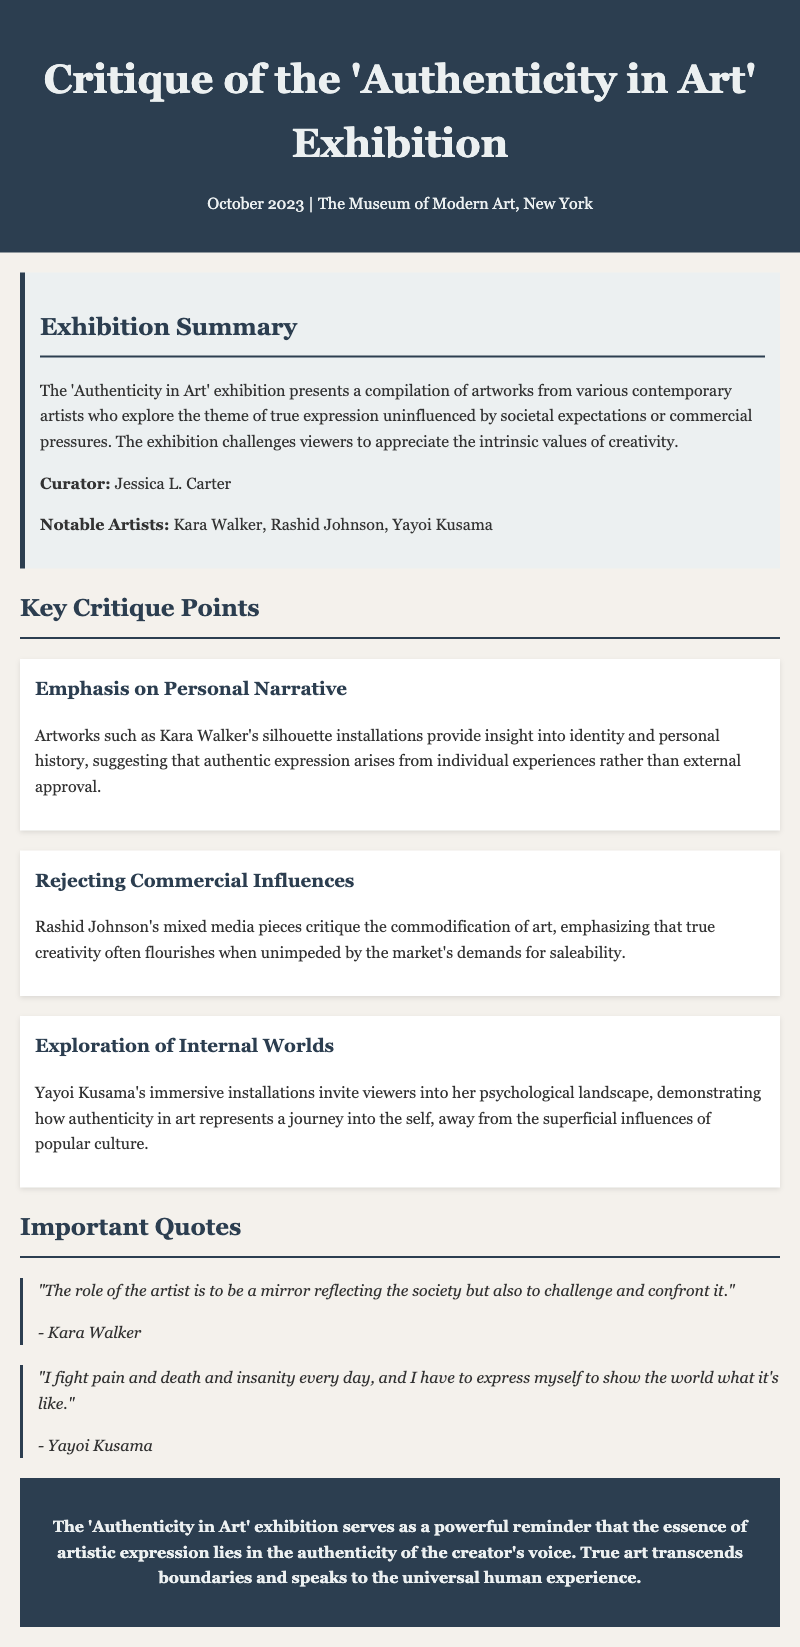What is the title of the exhibition? The title of the exhibition is found in the header of the document, which states "Critique of the 'Authenticity in Art' Exhibition."
Answer: 'Authenticity in Art' Who is the curator of the exhibition? The curator's name is mentioned in the exhibition summary section under "Curator."
Answer: Jessica L. Carter Which artist is known for silhouette installations? The artist who created silhouette installations is identified in the critique points section related to personal narrative.
Answer: Kara Walker What theme does Rashid Johnson's work critique? The theme of Rashid Johnson's works is described as a critique of commercial influences in the critique points.
Answer: Commodification of art What does Yayoi Kusama's installations represent? The representation of Yayoi Kusama's installations is detailed in the critique points section describing her art's journey.
Answer: Psychological landscape How many notable artists are mentioned in the document? The exhibition summary lists the notable artists, and counting them gives the answer.
Answer: Three What does the conclusion emphasize about artistic expression? The conclusion summarizes a key point regarding the essence of artistic expression discussed throughout the document.
Answer: Authenticity of the creator's voice Who said, "I fight pain and death and insanity every day"? This quote is attributed to an artist listed in the important quotes section.
Answer: Yayoi Kusama 